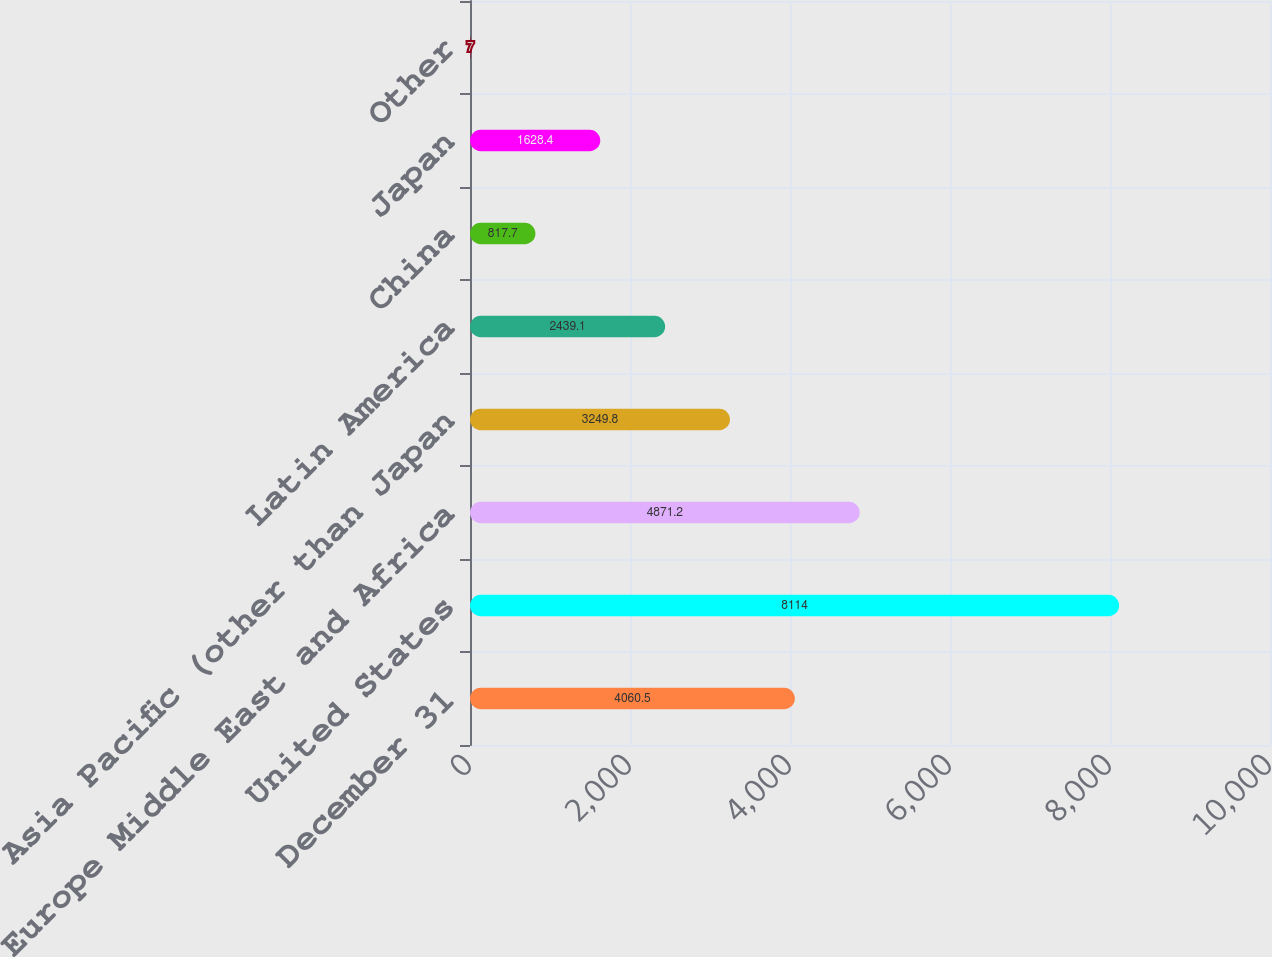Convert chart. <chart><loc_0><loc_0><loc_500><loc_500><bar_chart><fcel>December 31<fcel>United States<fcel>Europe Middle East and Africa<fcel>Asia Pacific (other than Japan<fcel>Latin America<fcel>China<fcel>Japan<fcel>Other<nl><fcel>4060.5<fcel>8114<fcel>4871.2<fcel>3249.8<fcel>2439.1<fcel>817.7<fcel>1628.4<fcel>7<nl></chart> 